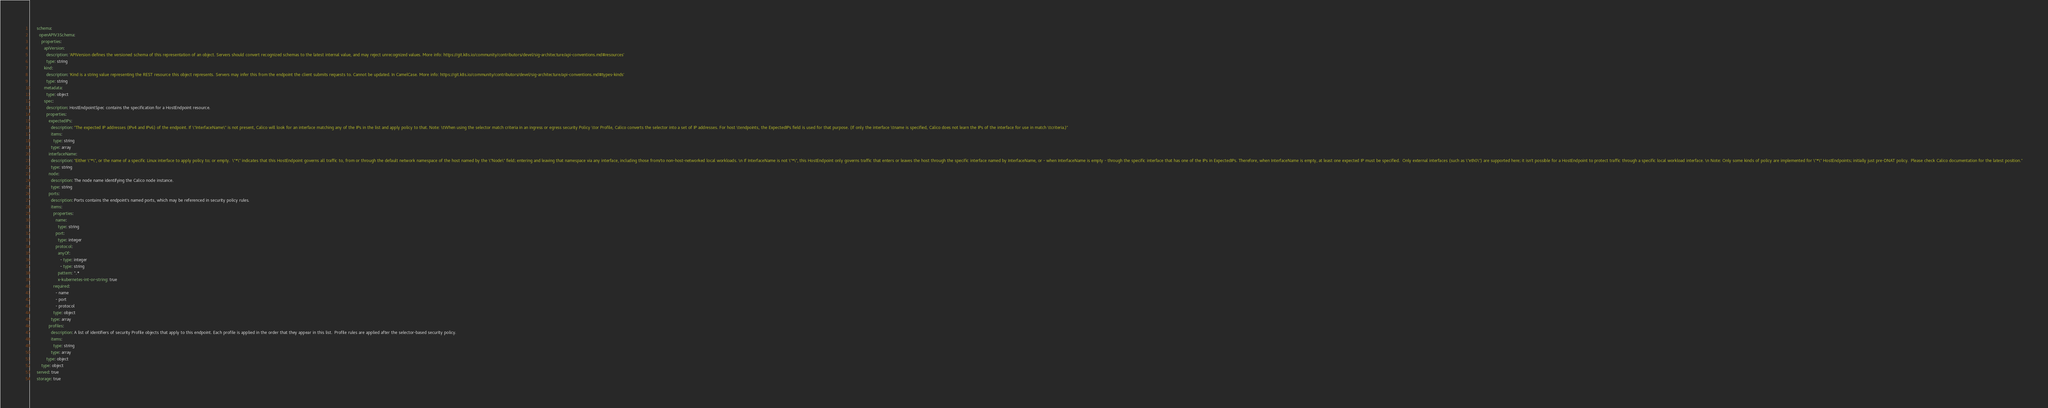<code> <loc_0><loc_0><loc_500><loc_500><_YAML_>      schema:
        openAPIV3Schema:
          properties:
            apiVersion:
              description: 'APIVersion defines the versioned schema of this representation of an object. Servers should convert recognized schemas to the latest internal value, and may reject unrecognized values. More info: https://git.k8s.io/community/contributors/devel/sig-architecture/api-conventions.md#resources'
              type: string
            kind:
              description: 'Kind is a string value representing the REST resource this object represents. Servers may infer this from the endpoint the client submits requests to. Cannot be updated. In CamelCase. More info: https://git.k8s.io/community/contributors/devel/sig-architecture/api-conventions.md#types-kinds'
              type: string
            metadata:
              type: object
            spec:
              description: HostEndpointSpec contains the specification for a HostEndpoint resource.
              properties:
                expectedIPs:
                  description: "The expected IP addresses (IPv4 and IPv6) of the endpoint. If \"InterfaceName\" is not present, Calico will look for an interface matching any of the IPs in the list and apply policy to that. Note: \tWhen using the selector match criteria in an ingress or egress security Policy \tor Profile, Calico converts the selector into a set of IP addresses. For host \tendpoints, the ExpectedIPs field is used for that purpose. (If only the interface \tname is specified, Calico does not learn the IPs of the interface for use in match \tcriteria.)"
                  items:
                    type: string
                  type: array
                interfaceName:
                  description: "Either \"*\", or the name of a specific Linux interface to apply policy to; or empty.  \"*\" indicates that this HostEndpoint governs all traffic to, from or through the default network namespace of the host named by the \"Node\" field; entering and leaving that namespace via any interface, including those from/to non-host-networked local workloads. \n If InterfaceName is not \"*\", this HostEndpoint only governs traffic that enters or leaves the host through the specific interface named by InterfaceName, or - when InterfaceName is empty - through the specific interface that has one of the IPs in ExpectedIPs. Therefore, when InterfaceName is empty, at least one expected IP must be specified.  Only external interfaces (such as \"eth0\") are supported here; it isn't possible for a HostEndpoint to protect traffic through a specific local workload interface. \n Note: Only some kinds of policy are implemented for \"*\" HostEndpoints; initially just pre-DNAT policy.  Please check Calico documentation for the latest position."
                  type: string
                node:
                  description: The node name identifying the Calico node instance.
                  type: string
                ports:
                  description: Ports contains the endpoint's named ports, which may be referenced in security policy rules.
                  items:
                    properties:
                      name:
                        type: string
                      port:
                        type: integer
                      protocol:
                        anyOf:
                          - type: integer
                          - type: string
                        pattern: ^.*
                        x-kubernetes-int-or-string: true
                    required:
                      - name
                      - port
                      - protocol
                    type: object
                  type: array
                profiles:
                  description: A list of identifiers of security Profile objects that apply to this endpoint. Each profile is applied in the order that they appear in this list.  Profile rules are applied after the selector-based security policy.
                  items:
                    type: string
                  type: array
              type: object
          type: object
      served: true
      storage: true
</code> 